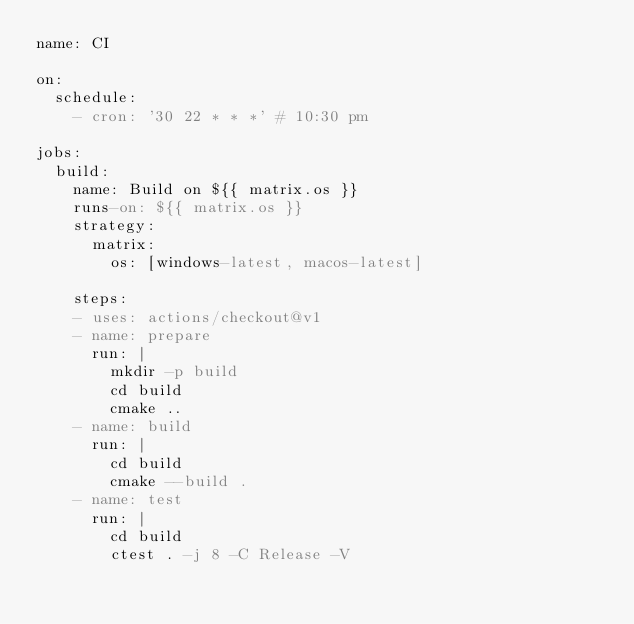Convert code to text. <code><loc_0><loc_0><loc_500><loc_500><_YAML_>name: CI

on:
  schedule:
    - cron: '30 22 * * *' # 10:30 pm

jobs:
  build:
    name: Build on ${{ matrix.os }}
    runs-on: ${{ matrix.os }}
    strategy:
      matrix:
        os: [windows-latest, macos-latest]

    steps:
    - uses: actions/checkout@v1
    - name: prepare
      run: |
        mkdir -p build
        cd build
        cmake ..
    - name: build
      run: |
        cd build
        cmake --build .
    - name: test
      run: |
        cd build
        ctest . -j 8 -C Release -V
</code> 